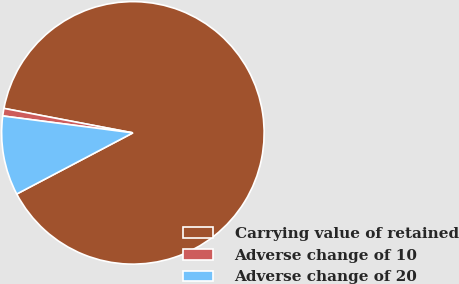Convert chart to OTSL. <chart><loc_0><loc_0><loc_500><loc_500><pie_chart><fcel>Carrying value of retained<fcel>Adverse change of 10<fcel>Adverse change of 20<nl><fcel>89.3%<fcel>0.93%<fcel>9.77%<nl></chart> 